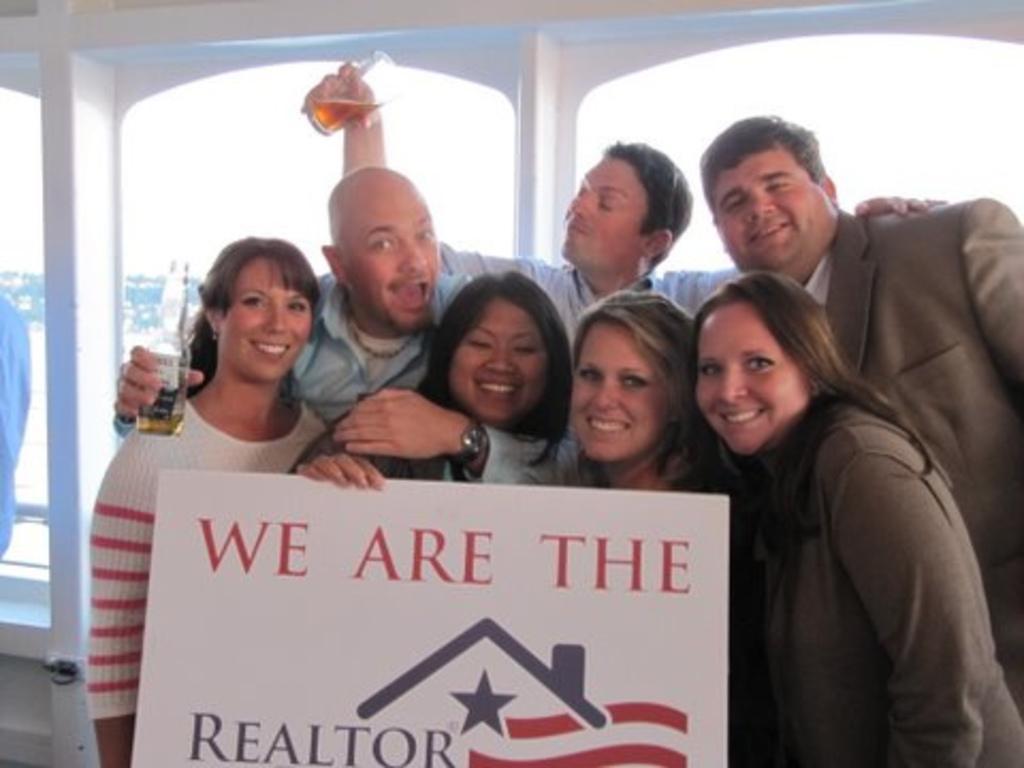Can you describe this image briefly? In the image in the center, we can see a few people are standing and smiling, which we can see on their faces. And the center person is holding a banner. And we can see two persons are holding wine glasses. In the background there is a wall, glass and a few other objects. 